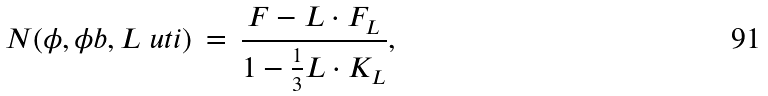Convert formula to latex. <formula><loc_0><loc_0><loc_500><loc_500>N ( \phi , \phi b , L ^ { \ } u t i ) \, = \, \frac { F - L \cdot F _ { L } } { 1 - \frac { 1 } { 3 } L \cdot K _ { L } } ,</formula> 